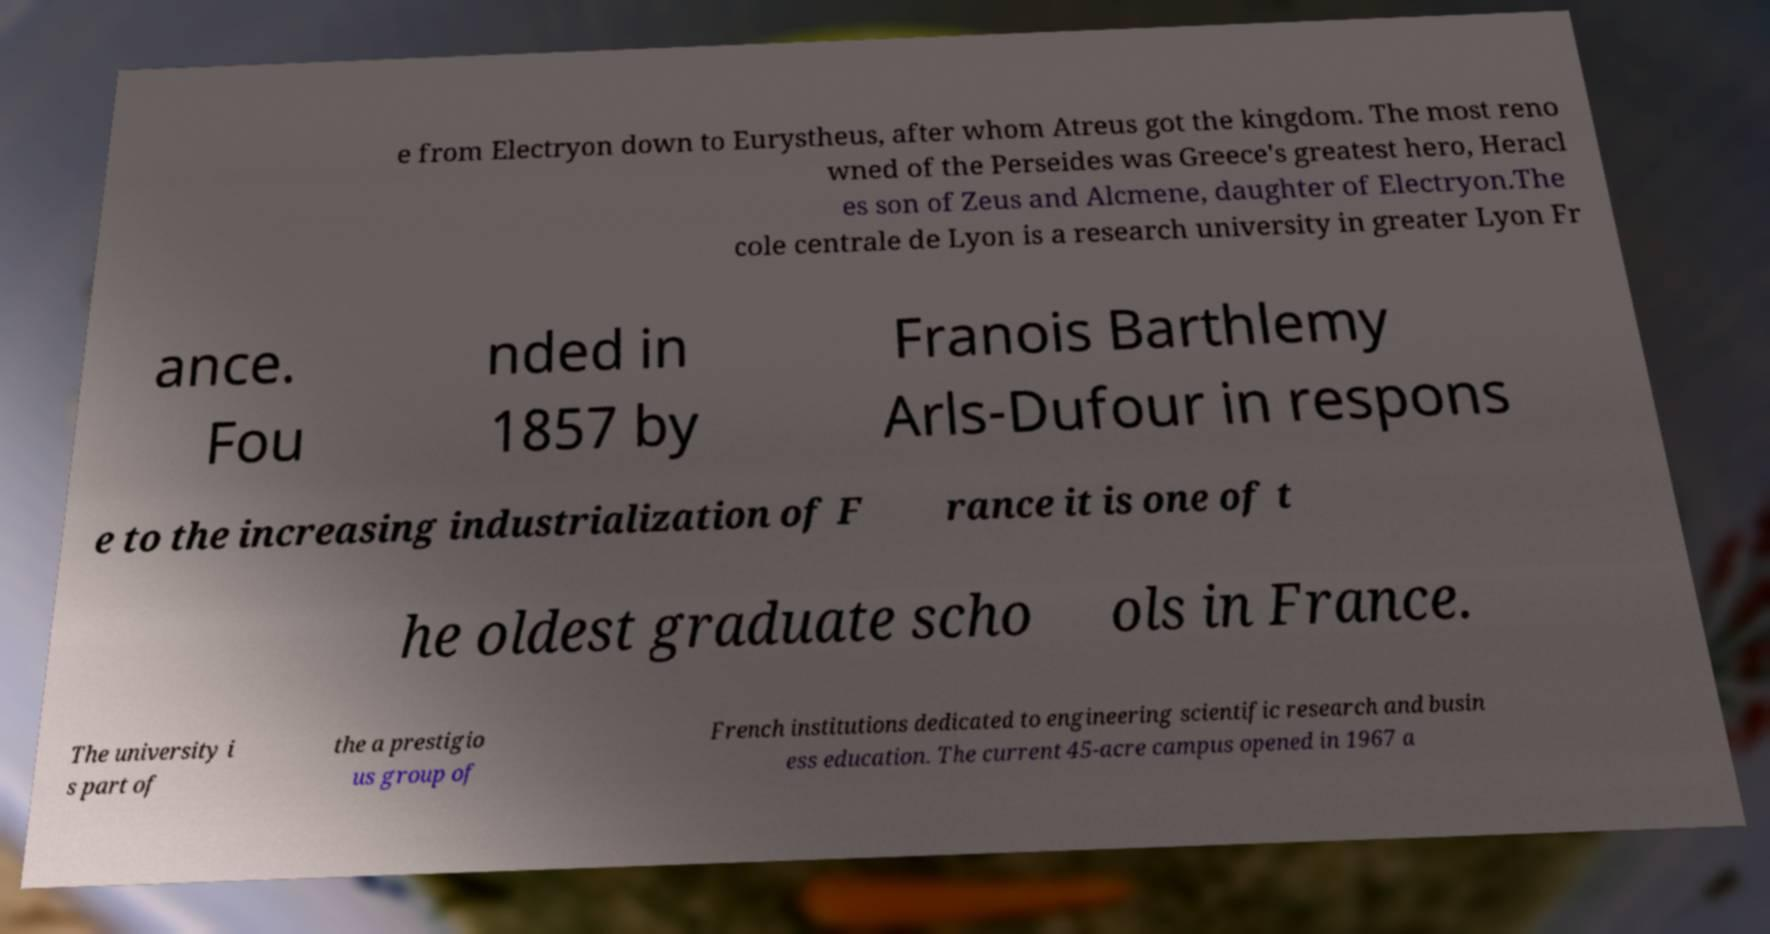What messages or text are displayed in this image? I need them in a readable, typed format. e from Electryon down to Eurystheus, after whom Atreus got the kingdom. The most reno wned of the Perseides was Greece's greatest hero, Heracl es son of Zeus and Alcmene, daughter of Electryon.The cole centrale de Lyon is a research university in greater Lyon Fr ance. Fou nded in 1857 by Franois Barthlemy Arls-Dufour in respons e to the increasing industrialization of F rance it is one of t he oldest graduate scho ols in France. The university i s part of the a prestigio us group of French institutions dedicated to engineering scientific research and busin ess education. The current 45-acre campus opened in 1967 a 